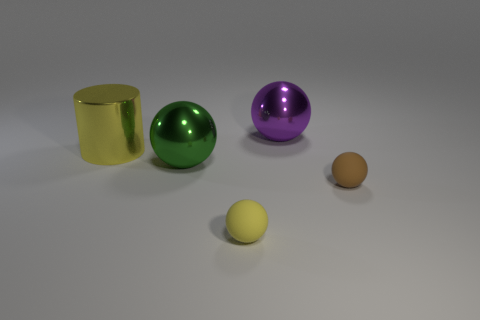Is the size of the green shiny sphere the same as the purple metallic object?
Your answer should be compact. Yes. There is a yellow metal object that is on the left side of the sphere in front of the brown rubber thing; how big is it?
Make the answer very short. Large. How big is the shiny thing that is to the left of the yellow ball and on the right side of the big metal cylinder?
Ensure brevity in your answer.  Large. How many purple balls are the same size as the yellow rubber object?
Provide a short and direct response. 0. What number of metal things are tiny spheres or spheres?
Keep it short and to the point. 2. There is a rubber ball that is the same color as the large metal cylinder; what is its size?
Make the answer very short. Small. The tiny sphere in front of the object to the right of the big purple ball is made of what material?
Your answer should be compact. Rubber. What number of things are either big green shiny spheres or small brown rubber balls that are right of the tiny yellow matte sphere?
Provide a short and direct response. 2. The green object that is the same material as the large purple sphere is what size?
Ensure brevity in your answer.  Large. What number of cyan things are big metallic cylinders or small matte things?
Your answer should be compact. 0. 